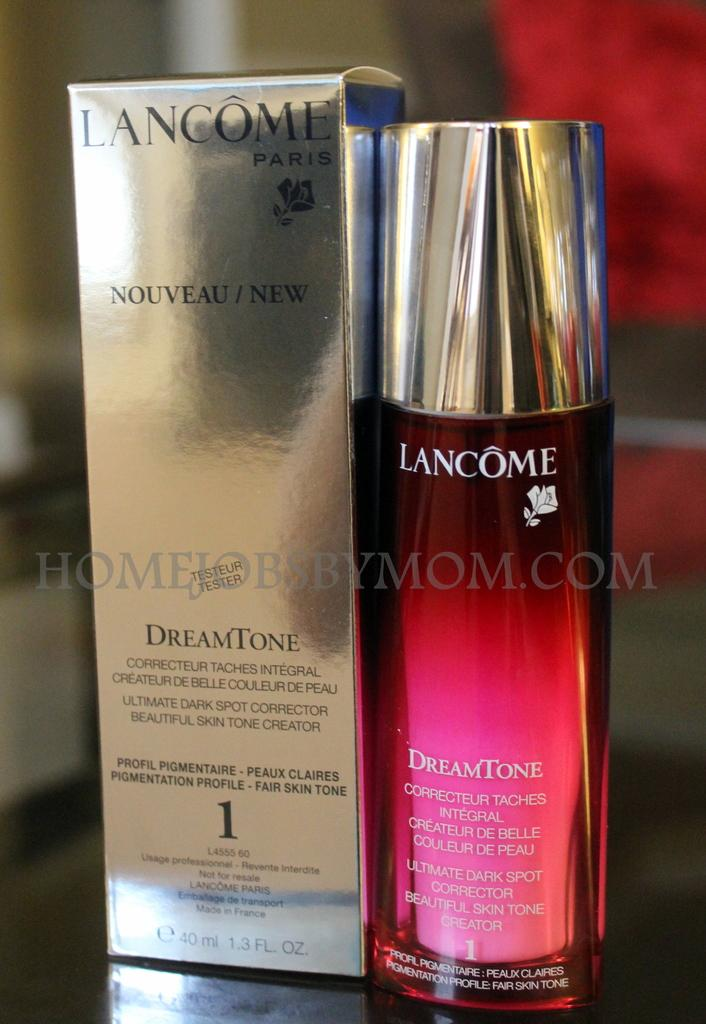<image>
Summarize the visual content of the image. a bottle of Lancome DreamTone stands next to a silver box. 